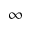Convert formula to latex. <formula><loc_0><loc_0><loc_500><loc_500>\infty</formula> 